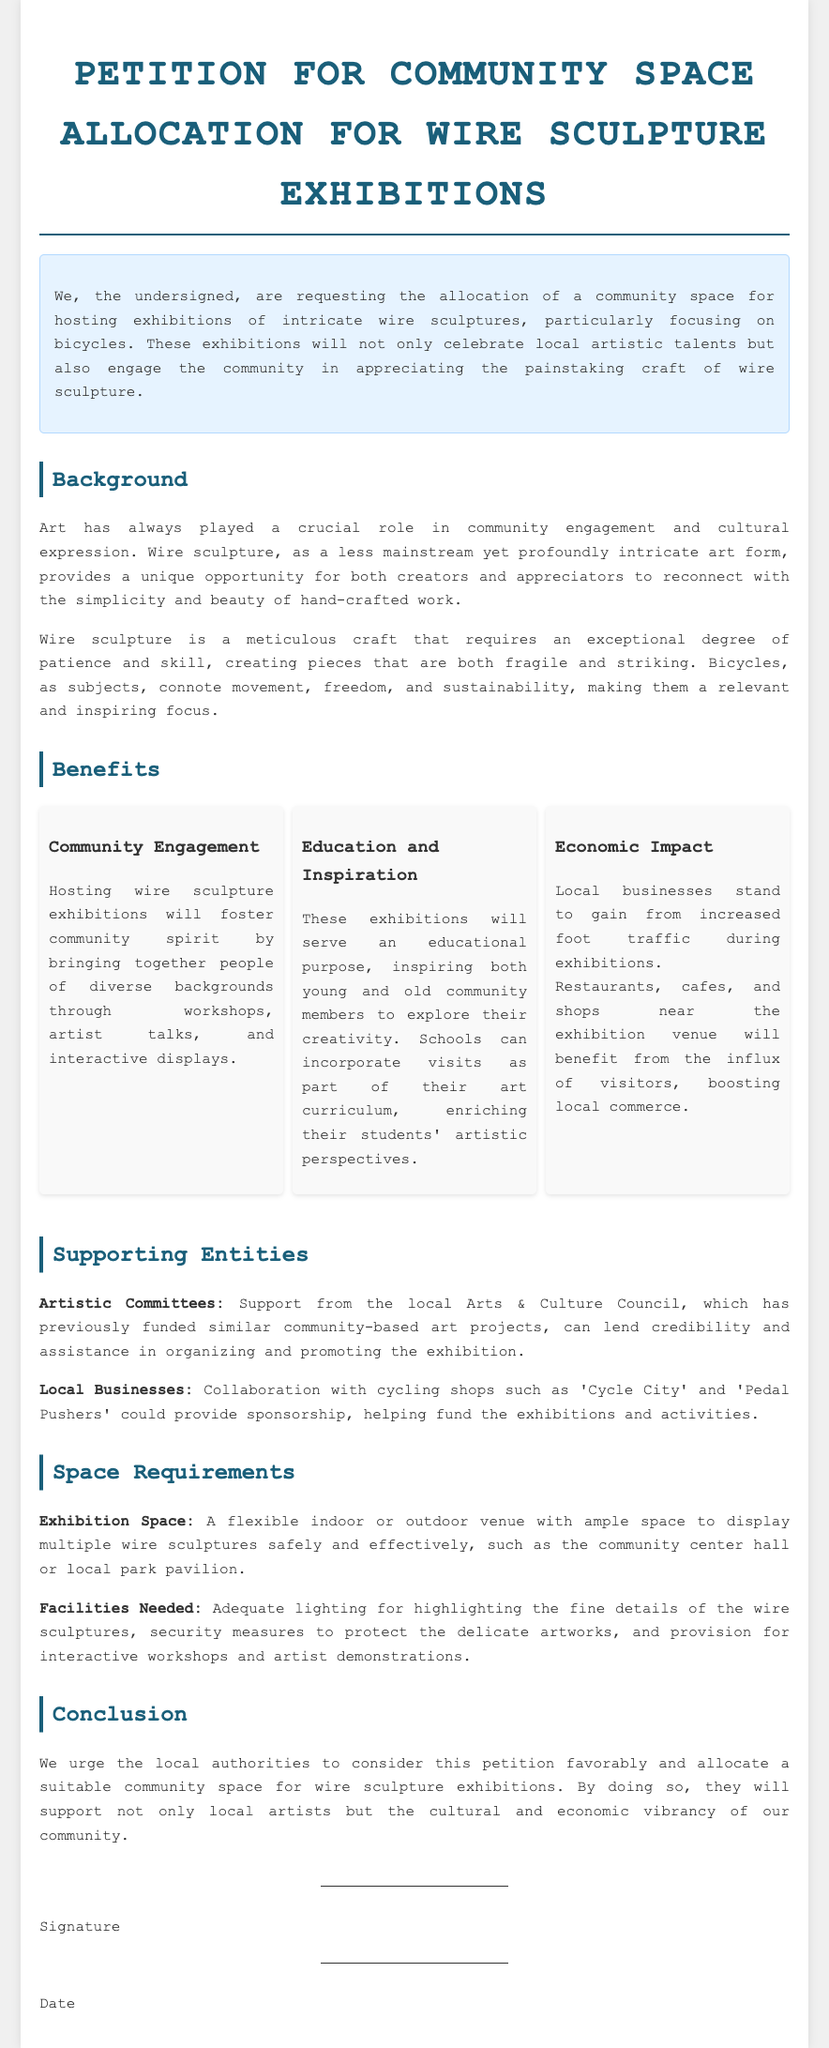What is the title of the document? The title of the document is prominently displayed at the top of the rendered petition.
Answer: Petition for Community Space Allocation for Wire Sculpture Exhibitions What is the main focus of the wire sculptures? The document specifically mentions the subject focus for wire sculptures being bicycles.
Answer: Bicycles Who are the supporting entities mentioned in the petition? The petition lists local Arts & Culture Council and local businesses as supporting entities.
Answer: Artistic Committees, Local Businesses What is one of the key benefits of hosting wire sculpture exhibitions? The document states that community engagement is a significant benefit from hosting the exhibitions.
Answer: Community Engagement What type of space is requested for the exhibitions? The petition specifies a flexible indoor or outdoor venue as the type of space needed.
Answer: Flexible indoor or outdoor venue What is a required facility for the exhibitions? Adequate lighting is mentioned in the document as a necessary facility for the exhibitions.
Answer: Adequate lighting What impact can local businesses expect from the exhibitions? The document states that local businesses will experience increased foot traffic during exhibitions.
Answer: Increased foot traffic What does the petition urge local authorities to do? The petition calls for local authorities to allocate a suitable community space for wire sculpture exhibitions.
Answer: Allocate a suitable community space What is the purpose of the exhibitions according to the petition? The petition indicates that the exhibitions will celebrate local artistic talents and engage the community.
Answer: Celebrate local artistic talents and engage the community 